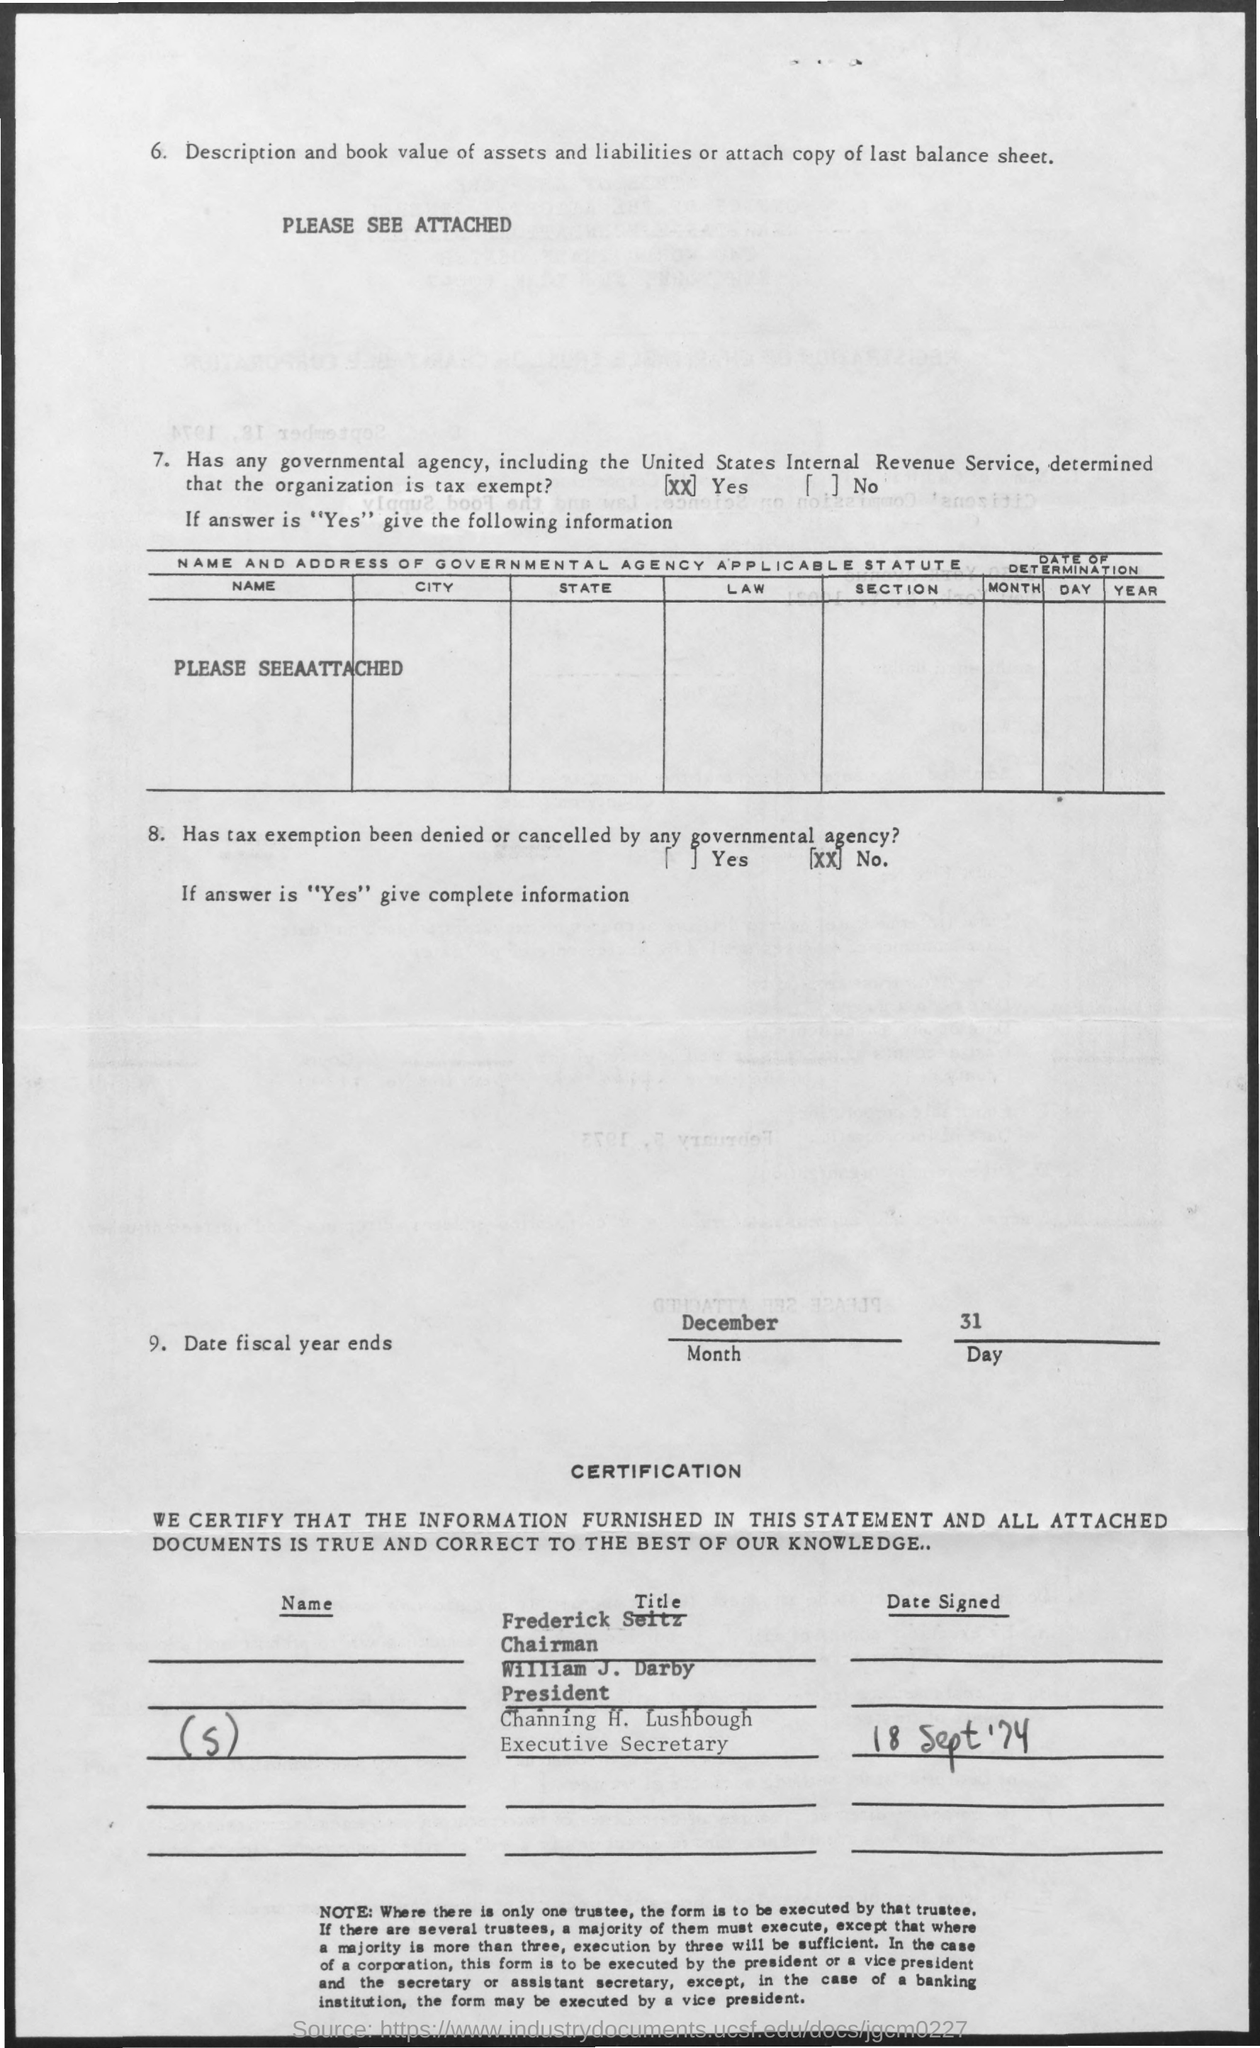Highlight a few significant elements in this photo. The Chairman is Frederick Seitz. Channing H. Lushbough's designation is Executive Secretary. 